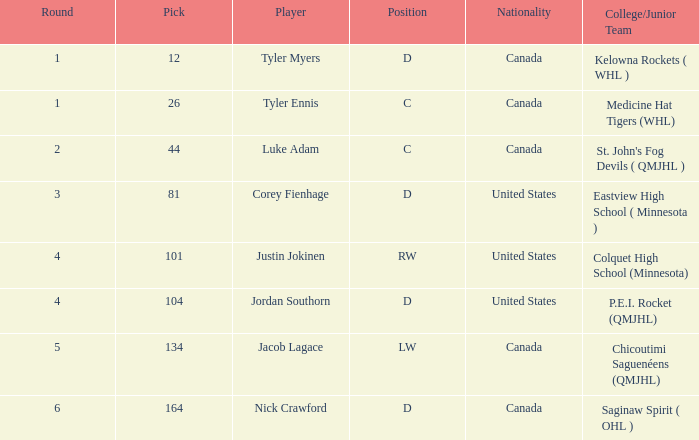What is the sum of the pick of the lw position player? 134.0. 